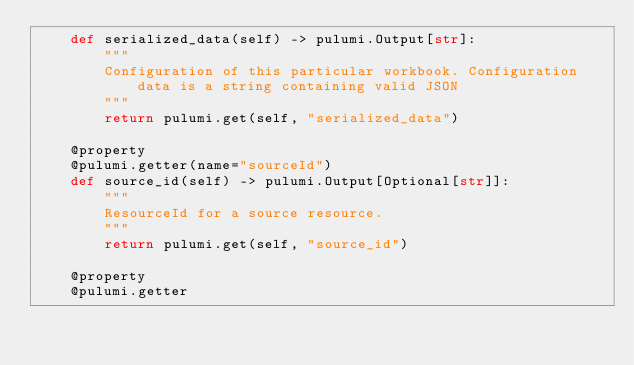Convert code to text. <code><loc_0><loc_0><loc_500><loc_500><_Python_>    def serialized_data(self) -> pulumi.Output[str]:
        """
        Configuration of this particular workbook. Configuration data is a string containing valid JSON
        """
        return pulumi.get(self, "serialized_data")

    @property
    @pulumi.getter(name="sourceId")
    def source_id(self) -> pulumi.Output[Optional[str]]:
        """
        ResourceId for a source resource.
        """
        return pulumi.get(self, "source_id")

    @property
    @pulumi.getter</code> 